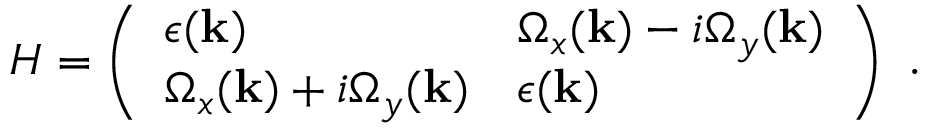<formula> <loc_0><loc_0><loc_500><loc_500>\begin{array} { r } { H = \left ( \begin{array} { l l } { \epsilon ( k ) } & { \Omega _ { x } ( k ) - i \Omega _ { y } ( k ) } \\ { \Omega _ { x } ( k ) + i \Omega _ { y } ( k ) } & { \epsilon ( k ) } \end{array} \right ) . } \end{array}</formula> 